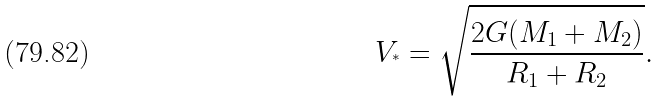<formula> <loc_0><loc_0><loc_500><loc_500>V _ { ^ { * } } = \sqrt { \frac { 2 G ( M _ { 1 } + M _ { 2 } ) } { R _ { 1 } + R _ { 2 } } } .</formula> 